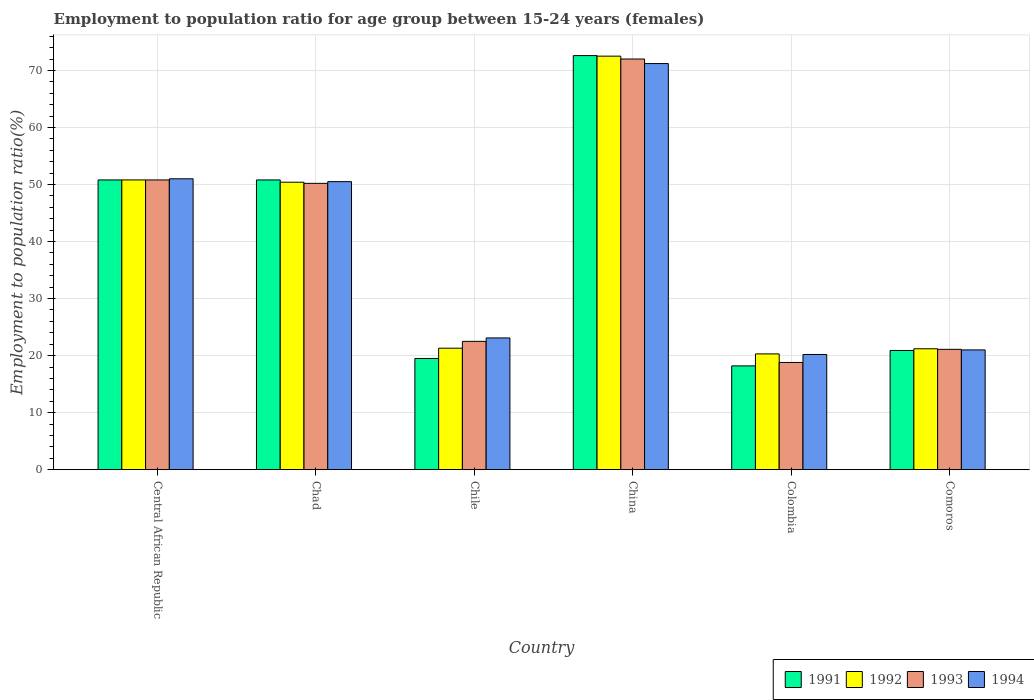How many different coloured bars are there?
Ensure brevity in your answer.  4. Are the number of bars per tick equal to the number of legend labels?
Provide a short and direct response. Yes. How many bars are there on the 5th tick from the left?
Make the answer very short. 4. How many bars are there on the 2nd tick from the right?
Make the answer very short. 4. What is the label of the 5th group of bars from the left?
Provide a short and direct response. Colombia. In how many cases, is the number of bars for a given country not equal to the number of legend labels?
Your response must be concise. 0. What is the employment to population ratio in 1991 in Central African Republic?
Give a very brief answer. 50.8. Across all countries, what is the maximum employment to population ratio in 1994?
Provide a succinct answer. 71.2. Across all countries, what is the minimum employment to population ratio in 1991?
Your answer should be compact. 18.2. In which country was the employment to population ratio in 1991 maximum?
Offer a very short reply. China. What is the total employment to population ratio in 1992 in the graph?
Your answer should be compact. 236.5. What is the difference between the employment to population ratio in 1993 in Chad and that in Colombia?
Provide a short and direct response. 31.4. What is the difference between the employment to population ratio in 1991 in Chile and the employment to population ratio in 1992 in Chad?
Make the answer very short. -30.9. What is the average employment to population ratio in 1991 per country?
Offer a terse response. 38.8. What is the difference between the employment to population ratio of/in 1991 and employment to population ratio of/in 1992 in Central African Republic?
Offer a terse response. 0. What is the ratio of the employment to population ratio in 1992 in China to that in Colombia?
Offer a very short reply. 3.57. Is the employment to population ratio in 1991 in Colombia less than that in Comoros?
Your answer should be very brief. Yes. What is the difference between the highest and the lowest employment to population ratio in 1992?
Provide a short and direct response. 52.2. Is the sum of the employment to population ratio in 1993 in Chad and Colombia greater than the maximum employment to population ratio in 1994 across all countries?
Make the answer very short. No. Is it the case that in every country, the sum of the employment to population ratio in 1994 and employment to population ratio in 1992 is greater than the employment to population ratio in 1991?
Make the answer very short. Yes. Are all the bars in the graph horizontal?
Offer a terse response. No. What is the difference between two consecutive major ticks on the Y-axis?
Make the answer very short. 10. Where does the legend appear in the graph?
Keep it short and to the point. Bottom right. How many legend labels are there?
Your answer should be very brief. 4. How are the legend labels stacked?
Provide a short and direct response. Horizontal. What is the title of the graph?
Ensure brevity in your answer.  Employment to population ratio for age group between 15-24 years (females). What is the Employment to population ratio(%) of 1991 in Central African Republic?
Ensure brevity in your answer.  50.8. What is the Employment to population ratio(%) of 1992 in Central African Republic?
Offer a very short reply. 50.8. What is the Employment to population ratio(%) in 1993 in Central African Republic?
Ensure brevity in your answer.  50.8. What is the Employment to population ratio(%) in 1994 in Central African Republic?
Provide a short and direct response. 51. What is the Employment to population ratio(%) in 1991 in Chad?
Your response must be concise. 50.8. What is the Employment to population ratio(%) of 1992 in Chad?
Provide a succinct answer. 50.4. What is the Employment to population ratio(%) in 1993 in Chad?
Offer a terse response. 50.2. What is the Employment to population ratio(%) in 1994 in Chad?
Your answer should be very brief. 50.5. What is the Employment to population ratio(%) in 1992 in Chile?
Provide a short and direct response. 21.3. What is the Employment to population ratio(%) of 1994 in Chile?
Make the answer very short. 23.1. What is the Employment to population ratio(%) in 1991 in China?
Offer a terse response. 72.6. What is the Employment to population ratio(%) in 1992 in China?
Give a very brief answer. 72.5. What is the Employment to population ratio(%) in 1994 in China?
Offer a very short reply. 71.2. What is the Employment to population ratio(%) in 1991 in Colombia?
Keep it short and to the point. 18.2. What is the Employment to population ratio(%) of 1992 in Colombia?
Offer a terse response. 20.3. What is the Employment to population ratio(%) in 1993 in Colombia?
Offer a terse response. 18.8. What is the Employment to population ratio(%) of 1994 in Colombia?
Provide a succinct answer. 20.2. What is the Employment to population ratio(%) in 1991 in Comoros?
Keep it short and to the point. 20.9. What is the Employment to population ratio(%) in 1992 in Comoros?
Offer a terse response. 21.2. What is the Employment to population ratio(%) in 1993 in Comoros?
Give a very brief answer. 21.1. What is the Employment to population ratio(%) of 1994 in Comoros?
Make the answer very short. 21. Across all countries, what is the maximum Employment to population ratio(%) in 1991?
Make the answer very short. 72.6. Across all countries, what is the maximum Employment to population ratio(%) in 1992?
Your answer should be compact. 72.5. Across all countries, what is the maximum Employment to population ratio(%) in 1993?
Provide a succinct answer. 72. Across all countries, what is the maximum Employment to population ratio(%) of 1994?
Give a very brief answer. 71.2. Across all countries, what is the minimum Employment to population ratio(%) in 1991?
Your answer should be very brief. 18.2. Across all countries, what is the minimum Employment to population ratio(%) of 1992?
Provide a short and direct response. 20.3. Across all countries, what is the minimum Employment to population ratio(%) of 1993?
Your answer should be compact. 18.8. Across all countries, what is the minimum Employment to population ratio(%) in 1994?
Make the answer very short. 20.2. What is the total Employment to population ratio(%) of 1991 in the graph?
Offer a very short reply. 232.8. What is the total Employment to population ratio(%) of 1992 in the graph?
Provide a short and direct response. 236.5. What is the total Employment to population ratio(%) in 1993 in the graph?
Offer a terse response. 235.4. What is the total Employment to population ratio(%) of 1994 in the graph?
Make the answer very short. 237. What is the difference between the Employment to population ratio(%) of 1991 in Central African Republic and that in Chad?
Your answer should be compact. 0. What is the difference between the Employment to population ratio(%) in 1992 in Central African Republic and that in Chad?
Provide a succinct answer. 0.4. What is the difference between the Employment to population ratio(%) in 1993 in Central African Republic and that in Chad?
Provide a short and direct response. 0.6. What is the difference between the Employment to population ratio(%) in 1991 in Central African Republic and that in Chile?
Offer a terse response. 31.3. What is the difference between the Employment to population ratio(%) of 1992 in Central African Republic and that in Chile?
Ensure brevity in your answer.  29.5. What is the difference between the Employment to population ratio(%) in 1993 in Central African Republic and that in Chile?
Provide a short and direct response. 28.3. What is the difference between the Employment to population ratio(%) of 1994 in Central African Republic and that in Chile?
Offer a very short reply. 27.9. What is the difference between the Employment to population ratio(%) in 1991 in Central African Republic and that in China?
Offer a very short reply. -21.8. What is the difference between the Employment to population ratio(%) in 1992 in Central African Republic and that in China?
Give a very brief answer. -21.7. What is the difference between the Employment to population ratio(%) in 1993 in Central African Republic and that in China?
Keep it short and to the point. -21.2. What is the difference between the Employment to population ratio(%) in 1994 in Central African Republic and that in China?
Offer a terse response. -20.2. What is the difference between the Employment to population ratio(%) in 1991 in Central African Republic and that in Colombia?
Offer a terse response. 32.6. What is the difference between the Employment to population ratio(%) of 1992 in Central African Republic and that in Colombia?
Your answer should be compact. 30.5. What is the difference between the Employment to population ratio(%) of 1994 in Central African Republic and that in Colombia?
Make the answer very short. 30.8. What is the difference between the Employment to population ratio(%) in 1991 in Central African Republic and that in Comoros?
Offer a terse response. 29.9. What is the difference between the Employment to population ratio(%) in 1992 in Central African Republic and that in Comoros?
Provide a succinct answer. 29.6. What is the difference between the Employment to population ratio(%) of 1993 in Central African Republic and that in Comoros?
Your response must be concise. 29.7. What is the difference between the Employment to population ratio(%) in 1991 in Chad and that in Chile?
Offer a terse response. 31.3. What is the difference between the Employment to population ratio(%) of 1992 in Chad and that in Chile?
Give a very brief answer. 29.1. What is the difference between the Employment to population ratio(%) in 1993 in Chad and that in Chile?
Your response must be concise. 27.7. What is the difference between the Employment to population ratio(%) in 1994 in Chad and that in Chile?
Your answer should be compact. 27.4. What is the difference between the Employment to population ratio(%) of 1991 in Chad and that in China?
Offer a very short reply. -21.8. What is the difference between the Employment to population ratio(%) in 1992 in Chad and that in China?
Your answer should be very brief. -22.1. What is the difference between the Employment to population ratio(%) of 1993 in Chad and that in China?
Offer a terse response. -21.8. What is the difference between the Employment to population ratio(%) in 1994 in Chad and that in China?
Keep it short and to the point. -20.7. What is the difference between the Employment to population ratio(%) in 1991 in Chad and that in Colombia?
Keep it short and to the point. 32.6. What is the difference between the Employment to population ratio(%) in 1992 in Chad and that in Colombia?
Your answer should be compact. 30.1. What is the difference between the Employment to population ratio(%) in 1993 in Chad and that in Colombia?
Offer a terse response. 31.4. What is the difference between the Employment to population ratio(%) in 1994 in Chad and that in Colombia?
Ensure brevity in your answer.  30.3. What is the difference between the Employment to population ratio(%) of 1991 in Chad and that in Comoros?
Ensure brevity in your answer.  29.9. What is the difference between the Employment to population ratio(%) in 1992 in Chad and that in Comoros?
Your answer should be compact. 29.2. What is the difference between the Employment to population ratio(%) of 1993 in Chad and that in Comoros?
Make the answer very short. 29.1. What is the difference between the Employment to population ratio(%) in 1994 in Chad and that in Comoros?
Offer a very short reply. 29.5. What is the difference between the Employment to population ratio(%) of 1991 in Chile and that in China?
Your answer should be compact. -53.1. What is the difference between the Employment to population ratio(%) in 1992 in Chile and that in China?
Provide a short and direct response. -51.2. What is the difference between the Employment to population ratio(%) in 1993 in Chile and that in China?
Ensure brevity in your answer.  -49.5. What is the difference between the Employment to population ratio(%) of 1994 in Chile and that in China?
Offer a terse response. -48.1. What is the difference between the Employment to population ratio(%) of 1992 in Chile and that in Colombia?
Offer a very short reply. 1. What is the difference between the Employment to population ratio(%) of 1994 in Chile and that in Colombia?
Your answer should be very brief. 2.9. What is the difference between the Employment to population ratio(%) of 1992 in Chile and that in Comoros?
Your response must be concise. 0.1. What is the difference between the Employment to population ratio(%) in 1994 in Chile and that in Comoros?
Ensure brevity in your answer.  2.1. What is the difference between the Employment to population ratio(%) in 1991 in China and that in Colombia?
Your response must be concise. 54.4. What is the difference between the Employment to population ratio(%) of 1992 in China and that in Colombia?
Keep it short and to the point. 52.2. What is the difference between the Employment to population ratio(%) in 1993 in China and that in Colombia?
Keep it short and to the point. 53.2. What is the difference between the Employment to population ratio(%) of 1994 in China and that in Colombia?
Keep it short and to the point. 51. What is the difference between the Employment to population ratio(%) in 1991 in China and that in Comoros?
Offer a terse response. 51.7. What is the difference between the Employment to population ratio(%) in 1992 in China and that in Comoros?
Make the answer very short. 51.3. What is the difference between the Employment to population ratio(%) in 1993 in China and that in Comoros?
Provide a short and direct response. 50.9. What is the difference between the Employment to population ratio(%) in 1994 in China and that in Comoros?
Keep it short and to the point. 50.2. What is the difference between the Employment to population ratio(%) of 1991 in Colombia and that in Comoros?
Keep it short and to the point. -2.7. What is the difference between the Employment to population ratio(%) of 1992 in Colombia and that in Comoros?
Ensure brevity in your answer.  -0.9. What is the difference between the Employment to population ratio(%) in 1994 in Colombia and that in Comoros?
Give a very brief answer. -0.8. What is the difference between the Employment to population ratio(%) in 1991 in Central African Republic and the Employment to population ratio(%) in 1993 in Chad?
Provide a succinct answer. 0.6. What is the difference between the Employment to population ratio(%) in 1991 in Central African Republic and the Employment to population ratio(%) in 1994 in Chad?
Make the answer very short. 0.3. What is the difference between the Employment to population ratio(%) in 1992 in Central African Republic and the Employment to population ratio(%) in 1993 in Chad?
Your response must be concise. 0.6. What is the difference between the Employment to population ratio(%) in 1992 in Central African Republic and the Employment to population ratio(%) in 1994 in Chad?
Give a very brief answer. 0.3. What is the difference between the Employment to population ratio(%) of 1991 in Central African Republic and the Employment to population ratio(%) of 1992 in Chile?
Make the answer very short. 29.5. What is the difference between the Employment to population ratio(%) in 1991 in Central African Republic and the Employment to population ratio(%) in 1993 in Chile?
Make the answer very short. 28.3. What is the difference between the Employment to population ratio(%) in 1991 in Central African Republic and the Employment to population ratio(%) in 1994 in Chile?
Provide a succinct answer. 27.7. What is the difference between the Employment to population ratio(%) in 1992 in Central African Republic and the Employment to population ratio(%) in 1993 in Chile?
Keep it short and to the point. 28.3. What is the difference between the Employment to population ratio(%) in 1992 in Central African Republic and the Employment to population ratio(%) in 1994 in Chile?
Your answer should be compact. 27.7. What is the difference between the Employment to population ratio(%) in 1993 in Central African Republic and the Employment to population ratio(%) in 1994 in Chile?
Give a very brief answer. 27.7. What is the difference between the Employment to population ratio(%) of 1991 in Central African Republic and the Employment to population ratio(%) of 1992 in China?
Keep it short and to the point. -21.7. What is the difference between the Employment to population ratio(%) in 1991 in Central African Republic and the Employment to population ratio(%) in 1993 in China?
Your answer should be compact. -21.2. What is the difference between the Employment to population ratio(%) in 1991 in Central African Republic and the Employment to population ratio(%) in 1994 in China?
Make the answer very short. -20.4. What is the difference between the Employment to population ratio(%) in 1992 in Central African Republic and the Employment to population ratio(%) in 1993 in China?
Provide a succinct answer. -21.2. What is the difference between the Employment to population ratio(%) in 1992 in Central African Republic and the Employment to population ratio(%) in 1994 in China?
Your answer should be very brief. -20.4. What is the difference between the Employment to population ratio(%) of 1993 in Central African Republic and the Employment to population ratio(%) of 1994 in China?
Your answer should be very brief. -20.4. What is the difference between the Employment to population ratio(%) in 1991 in Central African Republic and the Employment to population ratio(%) in 1992 in Colombia?
Give a very brief answer. 30.5. What is the difference between the Employment to population ratio(%) in 1991 in Central African Republic and the Employment to population ratio(%) in 1994 in Colombia?
Your response must be concise. 30.6. What is the difference between the Employment to population ratio(%) in 1992 in Central African Republic and the Employment to population ratio(%) in 1993 in Colombia?
Your answer should be compact. 32. What is the difference between the Employment to population ratio(%) in 1992 in Central African Republic and the Employment to population ratio(%) in 1994 in Colombia?
Make the answer very short. 30.6. What is the difference between the Employment to population ratio(%) of 1993 in Central African Republic and the Employment to population ratio(%) of 1994 in Colombia?
Your answer should be compact. 30.6. What is the difference between the Employment to population ratio(%) in 1991 in Central African Republic and the Employment to population ratio(%) in 1992 in Comoros?
Make the answer very short. 29.6. What is the difference between the Employment to population ratio(%) in 1991 in Central African Republic and the Employment to population ratio(%) in 1993 in Comoros?
Keep it short and to the point. 29.7. What is the difference between the Employment to population ratio(%) in 1991 in Central African Republic and the Employment to population ratio(%) in 1994 in Comoros?
Your response must be concise. 29.8. What is the difference between the Employment to population ratio(%) of 1992 in Central African Republic and the Employment to population ratio(%) of 1993 in Comoros?
Offer a terse response. 29.7. What is the difference between the Employment to population ratio(%) in 1992 in Central African Republic and the Employment to population ratio(%) in 1994 in Comoros?
Give a very brief answer. 29.8. What is the difference between the Employment to population ratio(%) of 1993 in Central African Republic and the Employment to population ratio(%) of 1994 in Comoros?
Provide a short and direct response. 29.8. What is the difference between the Employment to population ratio(%) of 1991 in Chad and the Employment to population ratio(%) of 1992 in Chile?
Offer a very short reply. 29.5. What is the difference between the Employment to population ratio(%) of 1991 in Chad and the Employment to population ratio(%) of 1993 in Chile?
Make the answer very short. 28.3. What is the difference between the Employment to population ratio(%) of 1991 in Chad and the Employment to population ratio(%) of 1994 in Chile?
Offer a very short reply. 27.7. What is the difference between the Employment to population ratio(%) in 1992 in Chad and the Employment to population ratio(%) in 1993 in Chile?
Your answer should be very brief. 27.9. What is the difference between the Employment to population ratio(%) of 1992 in Chad and the Employment to population ratio(%) of 1994 in Chile?
Your answer should be compact. 27.3. What is the difference between the Employment to population ratio(%) in 1993 in Chad and the Employment to population ratio(%) in 1994 in Chile?
Provide a succinct answer. 27.1. What is the difference between the Employment to population ratio(%) of 1991 in Chad and the Employment to population ratio(%) of 1992 in China?
Your response must be concise. -21.7. What is the difference between the Employment to population ratio(%) in 1991 in Chad and the Employment to population ratio(%) in 1993 in China?
Provide a succinct answer. -21.2. What is the difference between the Employment to population ratio(%) of 1991 in Chad and the Employment to population ratio(%) of 1994 in China?
Offer a very short reply. -20.4. What is the difference between the Employment to population ratio(%) of 1992 in Chad and the Employment to population ratio(%) of 1993 in China?
Offer a very short reply. -21.6. What is the difference between the Employment to population ratio(%) in 1992 in Chad and the Employment to population ratio(%) in 1994 in China?
Ensure brevity in your answer.  -20.8. What is the difference between the Employment to population ratio(%) in 1993 in Chad and the Employment to population ratio(%) in 1994 in China?
Make the answer very short. -21. What is the difference between the Employment to population ratio(%) of 1991 in Chad and the Employment to population ratio(%) of 1992 in Colombia?
Provide a short and direct response. 30.5. What is the difference between the Employment to population ratio(%) in 1991 in Chad and the Employment to population ratio(%) in 1993 in Colombia?
Your response must be concise. 32. What is the difference between the Employment to population ratio(%) in 1991 in Chad and the Employment to population ratio(%) in 1994 in Colombia?
Provide a short and direct response. 30.6. What is the difference between the Employment to population ratio(%) of 1992 in Chad and the Employment to population ratio(%) of 1993 in Colombia?
Your answer should be compact. 31.6. What is the difference between the Employment to population ratio(%) in 1992 in Chad and the Employment to population ratio(%) in 1994 in Colombia?
Provide a succinct answer. 30.2. What is the difference between the Employment to population ratio(%) in 1993 in Chad and the Employment to population ratio(%) in 1994 in Colombia?
Keep it short and to the point. 30. What is the difference between the Employment to population ratio(%) in 1991 in Chad and the Employment to population ratio(%) in 1992 in Comoros?
Ensure brevity in your answer.  29.6. What is the difference between the Employment to population ratio(%) of 1991 in Chad and the Employment to population ratio(%) of 1993 in Comoros?
Your answer should be compact. 29.7. What is the difference between the Employment to population ratio(%) of 1991 in Chad and the Employment to population ratio(%) of 1994 in Comoros?
Ensure brevity in your answer.  29.8. What is the difference between the Employment to population ratio(%) in 1992 in Chad and the Employment to population ratio(%) in 1993 in Comoros?
Provide a succinct answer. 29.3. What is the difference between the Employment to population ratio(%) in 1992 in Chad and the Employment to population ratio(%) in 1994 in Comoros?
Offer a very short reply. 29.4. What is the difference between the Employment to population ratio(%) of 1993 in Chad and the Employment to population ratio(%) of 1994 in Comoros?
Keep it short and to the point. 29.2. What is the difference between the Employment to population ratio(%) of 1991 in Chile and the Employment to population ratio(%) of 1992 in China?
Make the answer very short. -53. What is the difference between the Employment to population ratio(%) in 1991 in Chile and the Employment to population ratio(%) in 1993 in China?
Your response must be concise. -52.5. What is the difference between the Employment to population ratio(%) of 1991 in Chile and the Employment to population ratio(%) of 1994 in China?
Your answer should be very brief. -51.7. What is the difference between the Employment to population ratio(%) in 1992 in Chile and the Employment to population ratio(%) in 1993 in China?
Ensure brevity in your answer.  -50.7. What is the difference between the Employment to population ratio(%) of 1992 in Chile and the Employment to population ratio(%) of 1994 in China?
Keep it short and to the point. -49.9. What is the difference between the Employment to population ratio(%) of 1993 in Chile and the Employment to population ratio(%) of 1994 in China?
Your answer should be very brief. -48.7. What is the difference between the Employment to population ratio(%) in 1992 in Chile and the Employment to population ratio(%) in 1994 in Colombia?
Provide a short and direct response. 1.1. What is the difference between the Employment to population ratio(%) in 1993 in Chile and the Employment to population ratio(%) in 1994 in Colombia?
Keep it short and to the point. 2.3. What is the difference between the Employment to population ratio(%) in 1991 in Chile and the Employment to population ratio(%) in 1992 in Comoros?
Keep it short and to the point. -1.7. What is the difference between the Employment to population ratio(%) of 1992 in Chile and the Employment to population ratio(%) of 1993 in Comoros?
Your answer should be compact. 0.2. What is the difference between the Employment to population ratio(%) of 1993 in Chile and the Employment to population ratio(%) of 1994 in Comoros?
Offer a terse response. 1.5. What is the difference between the Employment to population ratio(%) of 1991 in China and the Employment to population ratio(%) of 1992 in Colombia?
Provide a short and direct response. 52.3. What is the difference between the Employment to population ratio(%) in 1991 in China and the Employment to population ratio(%) in 1993 in Colombia?
Your answer should be compact. 53.8. What is the difference between the Employment to population ratio(%) of 1991 in China and the Employment to population ratio(%) of 1994 in Colombia?
Provide a short and direct response. 52.4. What is the difference between the Employment to population ratio(%) of 1992 in China and the Employment to population ratio(%) of 1993 in Colombia?
Offer a very short reply. 53.7. What is the difference between the Employment to population ratio(%) of 1992 in China and the Employment to population ratio(%) of 1994 in Colombia?
Your answer should be very brief. 52.3. What is the difference between the Employment to population ratio(%) of 1993 in China and the Employment to population ratio(%) of 1994 in Colombia?
Offer a terse response. 51.8. What is the difference between the Employment to population ratio(%) of 1991 in China and the Employment to population ratio(%) of 1992 in Comoros?
Give a very brief answer. 51.4. What is the difference between the Employment to population ratio(%) in 1991 in China and the Employment to population ratio(%) in 1993 in Comoros?
Your answer should be compact. 51.5. What is the difference between the Employment to population ratio(%) of 1991 in China and the Employment to population ratio(%) of 1994 in Comoros?
Provide a short and direct response. 51.6. What is the difference between the Employment to population ratio(%) in 1992 in China and the Employment to population ratio(%) in 1993 in Comoros?
Offer a terse response. 51.4. What is the difference between the Employment to population ratio(%) of 1992 in China and the Employment to population ratio(%) of 1994 in Comoros?
Give a very brief answer. 51.5. What is the difference between the Employment to population ratio(%) in 1991 in Colombia and the Employment to population ratio(%) in 1992 in Comoros?
Offer a very short reply. -3. What is the difference between the Employment to population ratio(%) in 1991 in Colombia and the Employment to population ratio(%) in 1993 in Comoros?
Give a very brief answer. -2.9. What is the difference between the Employment to population ratio(%) in 1992 in Colombia and the Employment to population ratio(%) in 1993 in Comoros?
Ensure brevity in your answer.  -0.8. What is the difference between the Employment to population ratio(%) in 1992 in Colombia and the Employment to population ratio(%) in 1994 in Comoros?
Your answer should be very brief. -0.7. What is the difference between the Employment to population ratio(%) in 1993 in Colombia and the Employment to population ratio(%) in 1994 in Comoros?
Keep it short and to the point. -2.2. What is the average Employment to population ratio(%) of 1991 per country?
Your response must be concise. 38.8. What is the average Employment to population ratio(%) in 1992 per country?
Offer a very short reply. 39.42. What is the average Employment to population ratio(%) in 1993 per country?
Ensure brevity in your answer.  39.23. What is the average Employment to population ratio(%) in 1994 per country?
Provide a succinct answer. 39.5. What is the difference between the Employment to population ratio(%) in 1991 and Employment to population ratio(%) in 1993 in Central African Republic?
Keep it short and to the point. 0. What is the difference between the Employment to population ratio(%) in 1992 and Employment to population ratio(%) in 1993 in Central African Republic?
Provide a short and direct response. 0. What is the difference between the Employment to population ratio(%) in 1991 and Employment to population ratio(%) in 1992 in Chad?
Offer a very short reply. 0.4. What is the difference between the Employment to population ratio(%) of 1991 and Employment to population ratio(%) of 1993 in Chad?
Give a very brief answer. 0.6. What is the difference between the Employment to population ratio(%) of 1991 and Employment to population ratio(%) of 1994 in Chad?
Offer a terse response. 0.3. What is the difference between the Employment to population ratio(%) in 1993 and Employment to population ratio(%) in 1994 in Chad?
Make the answer very short. -0.3. What is the difference between the Employment to population ratio(%) in 1991 and Employment to population ratio(%) in 1993 in Chile?
Give a very brief answer. -3. What is the difference between the Employment to population ratio(%) of 1991 and Employment to population ratio(%) of 1994 in Chile?
Keep it short and to the point. -3.6. What is the difference between the Employment to population ratio(%) of 1992 and Employment to population ratio(%) of 1994 in Chile?
Offer a terse response. -1.8. What is the difference between the Employment to population ratio(%) in 1991 and Employment to population ratio(%) in 1993 in China?
Offer a terse response. 0.6. What is the difference between the Employment to population ratio(%) in 1991 and Employment to population ratio(%) in 1994 in China?
Your answer should be very brief. 1.4. What is the difference between the Employment to population ratio(%) in 1992 and Employment to population ratio(%) in 1994 in China?
Offer a very short reply. 1.3. What is the difference between the Employment to population ratio(%) in 1991 and Employment to population ratio(%) in 1994 in Colombia?
Provide a short and direct response. -2. What is the difference between the Employment to population ratio(%) in 1991 and Employment to population ratio(%) in 1992 in Comoros?
Make the answer very short. -0.3. What is the difference between the Employment to population ratio(%) of 1992 and Employment to population ratio(%) of 1993 in Comoros?
Give a very brief answer. 0.1. What is the ratio of the Employment to population ratio(%) in 1992 in Central African Republic to that in Chad?
Ensure brevity in your answer.  1.01. What is the ratio of the Employment to population ratio(%) of 1993 in Central African Republic to that in Chad?
Your response must be concise. 1.01. What is the ratio of the Employment to population ratio(%) in 1994 in Central African Republic to that in Chad?
Offer a terse response. 1.01. What is the ratio of the Employment to population ratio(%) of 1991 in Central African Republic to that in Chile?
Provide a succinct answer. 2.61. What is the ratio of the Employment to population ratio(%) of 1992 in Central African Republic to that in Chile?
Ensure brevity in your answer.  2.38. What is the ratio of the Employment to population ratio(%) of 1993 in Central African Republic to that in Chile?
Offer a terse response. 2.26. What is the ratio of the Employment to population ratio(%) in 1994 in Central African Republic to that in Chile?
Offer a very short reply. 2.21. What is the ratio of the Employment to population ratio(%) of 1991 in Central African Republic to that in China?
Your answer should be very brief. 0.7. What is the ratio of the Employment to population ratio(%) in 1992 in Central African Republic to that in China?
Ensure brevity in your answer.  0.7. What is the ratio of the Employment to population ratio(%) in 1993 in Central African Republic to that in China?
Make the answer very short. 0.71. What is the ratio of the Employment to population ratio(%) in 1994 in Central African Republic to that in China?
Ensure brevity in your answer.  0.72. What is the ratio of the Employment to population ratio(%) in 1991 in Central African Republic to that in Colombia?
Make the answer very short. 2.79. What is the ratio of the Employment to population ratio(%) in 1992 in Central African Republic to that in Colombia?
Give a very brief answer. 2.5. What is the ratio of the Employment to population ratio(%) in 1993 in Central African Republic to that in Colombia?
Your answer should be compact. 2.7. What is the ratio of the Employment to population ratio(%) in 1994 in Central African Republic to that in Colombia?
Your answer should be compact. 2.52. What is the ratio of the Employment to population ratio(%) in 1991 in Central African Republic to that in Comoros?
Offer a terse response. 2.43. What is the ratio of the Employment to population ratio(%) in 1992 in Central African Republic to that in Comoros?
Make the answer very short. 2.4. What is the ratio of the Employment to population ratio(%) of 1993 in Central African Republic to that in Comoros?
Keep it short and to the point. 2.41. What is the ratio of the Employment to population ratio(%) in 1994 in Central African Republic to that in Comoros?
Give a very brief answer. 2.43. What is the ratio of the Employment to population ratio(%) of 1991 in Chad to that in Chile?
Your answer should be compact. 2.61. What is the ratio of the Employment to population ratio(%) of 1992 in Chad to that in Chile?
Offer a very short reply. 2.37. What is the ratio of the Employment to population ratio(%) in 1993 in Chad to that in Chile?
Your answer should be compact. 2.23. What is the ratio of the Employment to population ratio(%) in 1994 in Chad to that in Chile?
Offer a terse response. 2.19. What is the ratio of the Employment to population ratio(%) in 1991 in Chad to that in China?
Offer a terse response. 0.7. What is the ratio of the Employment to population ratio(%) of 1992 in Chad to that in China?
Provide a succinct answer. 0.7. What is the ratio of the Employment to population ratio(%) in 1993 in Chad to that in China?
Offer a terse response. 0.7. What is the ratio of the Employment to population ratio(%) of 1994 in Chad to that in China?
Your response must be concise. 0.71. What is the ratio of the Employment to population ratio(%) in 1991 in Chad to that in Colombia?
Offer a very short reply. 2.79. What is the ratio of the Employment to population ratio(%) in 1992 in Chad to that in Colombia?
Your answer should be compact. 2.48. What is the ratio of the Employment to population ratio(%) of 1993 in Chad to that in Colombia?
Make the answer very short. 2.67. What is the ratio of the Employment to population ratio(%) in 1991 in Chad to that in Comoros?
Ensure brevity in your answer.  2.43. What is the ratio of the Employment to population ratio(%) in 1992 in Chad to that in Comoros?
Give a very brief answer. 2.38. What is the ratio of the Employment to population ratio(%) of 1993 in Chad to that in Comoros?
Ensure brevity in your answer.  2.38. What is the ratio of the Employment to population ratio(%) of 1994 in Chad to that in Comoros?
Your answer should be very brief. 2.4. What is the ratio of the Employment to population ratio(%) in 1991 in Chile to that in China?
Provide a short and direct response. 0.27. What is the ratio of the Employment to population ratio(%) of 1992 in Chile to that in China?
Offer a very short reply. 0.29. What is the ratio of the Employment to population ratio(%) of 1993 in Chile to that in China?
Provide a succinct answer. 0.31. What is the ratio of the Employment to population ratio(%) of 1994 in Chile to that in China?
Keep it short and to the point. 0.32. What is the ratio of the Employment to population ratio(%) in 1991 in Chile to that in Colombia?
Your answer should be very brief. 1.07. What is the ratio of the Employment to population ratio(%) in 1992 in Chile to that in Colombia?
Give a very brief answer. 1.05. What is the ratio of the Employment to population ratio(%) in 1993 in Chile to that in Colombia?
Give a very brief answer. 1.2. What is the ratio of the Employment to population ratio(%) in 1994 in Chile to that in Colombia?
Make the answer very short. 1.14. What is the ratio of the Employment to population ratio(%) of 1991 in Chile to that in Comoros?
Ensure brevity in your answer.  0.93. What is the ratio of the Employment to population ratio(%) of 1992 in Chile to that in Comoros?
Offer a terse response. 1. What is the ratio of the Employment to population ratio(%) of 1993 in Chile to that in Comoros?
Offer a terse response. 1.07. What is the ratio of the Employment to population ratio(%) in 1991 in China to that in Colombia?
Provide a short and direct response. 3.99. What is the ratio of the Employment to population ratio(%) of 1992 in China to that in Colombia?
Keep it short and to the point. 3.57. What is the ratio of the Employment to population ratio(%) in 1993 in China to that in Colombia?
Provide a short and direct response. 3.83. What is the ratio of the Employment to population ratio(%) in 1994 in China to that in Colombia?
Offer a very short reply. 3.52. What is the ratio of the Employment to population ratio(%) of 1991 in China to that in Comoros?
Provide a succinct answer. 3.47. What is the ratio of the Employment to population ratio(%) in 1992 in China to that in Comoros?
Keep it short and to the point. 3.42. What is the ratio of the Employment to population ratio(%) of 1993 in China to that in Comoros?
Ensure brevity in your answer.  3.41. What is the ratio of the Employment to population ratio(%) of 1994 in China to that in Comoros?
Offer a very short reply. 3.39. What is the ratio of the Employment to population ratio(%) in 1991 in Colombia to that in Comoros?
Your answer should be compact. 0.87. What is the ratio of the Employment to population ratio(%) of 1992 in Colombia to that in Comoros?
Make the answer very short. 0.96. What is the ratio of the Employment to population ratio(%) in 1993 in Colombia to that in Comoros?
Offer a very short reply. 0.89. What is the ratio of the Employment to population ratio(%) of 1994 in Colombia to that in Comoros?
Offer a terse response. 0.96. What is the difference between the highest and the second highest Employment to population ratio(%) in 1991?
Keep it short and to the point. 21.8. What is the difference between the highest and the second highest Employment to population ratio(%) in 1992?
Your answer should be compact. 21.7. What is the difference between the highest and the second highest Employment to population ratio(%) of 1993?
Provide a short and direct response. 21.2. What is the difference between the highest and the second highest Employment to population ratio(%) of 1994?
Offer a terse response. 20.2. What is the difference between the highest and the lowest Employment to population ratio(%) of 1991?
Ensure brevity in your answer.  54.4. What is the difference between the highest and the lowest Employment to population ratio(%) in 1992?
Your answer should be compact. 52.2. What is the difference between the highest and the lowest Employment to population ratio(%) in 1993?
Give a very brief answer. 53.2. 